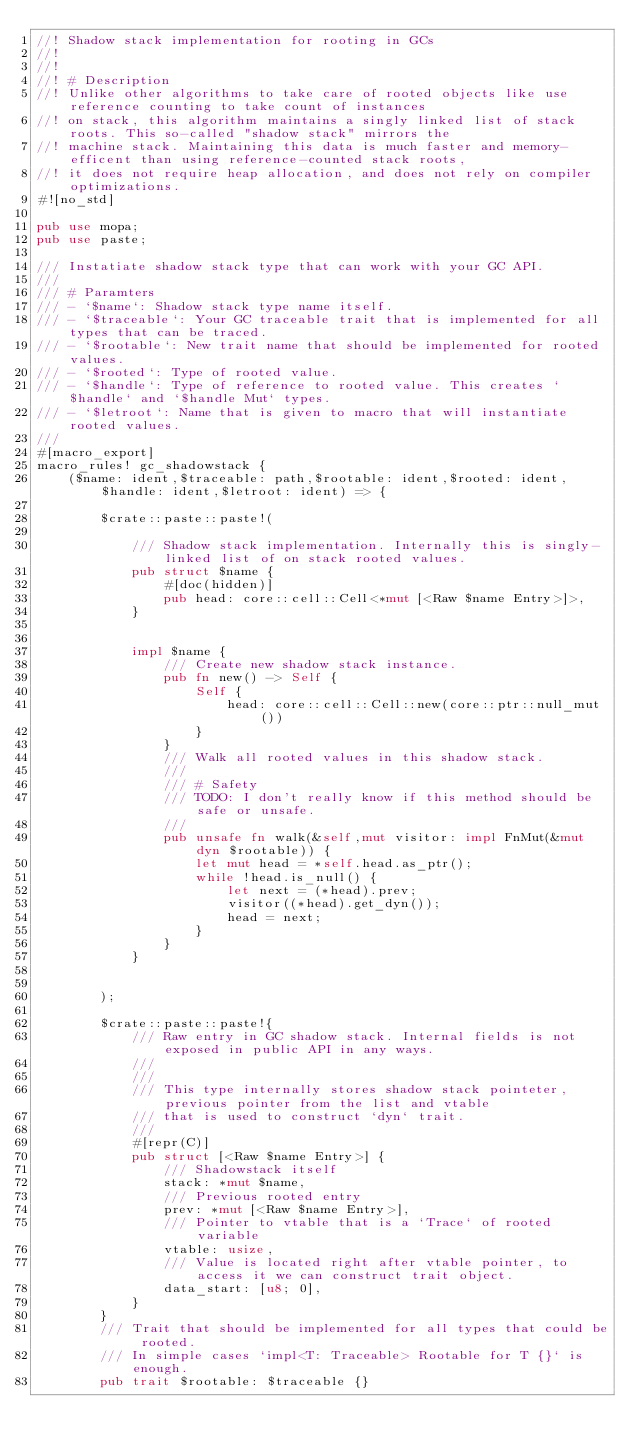Convert code to text. <code><loc_0><loc_0><loc_500><loc_500><_Rust_>//! Shadow stack implementation for rooting in GCs
//!
//!
//! # Description
//! Unlike other algorithms to take care of rooted objects like use reference counting to take count of instances
//! on stack, this algorithm maintains a singly linked list of stack roots. This so-called "shadow stack" mirrors the
//! machine stack. Maintaining this data is much faster and memory-efficent than using reference-counted stack roots,
//! it does not require heap allocation, and does not rely on compiler optimizations.
#![no_std]

pub use mopa;
pub use paste;

/// Instatiate shadow stack type that can work with your GC API.
///
/// # Paramters
/// - `$name`: Shadow stack type name itself.
/// - `$traceable`: Your GC traceable trait that is implemented for all types that can be traced.
/// - `$rootable`: New trait name that should be implemented for rooted values.
/// - `$rooted`: Type of rooted value.
/// - `$handle`: Type of reference to rooted value. This creates `$handle` and `$handle Mut` types.
/// - `$letroot`: Name that is given to macro that will instantiate rooted values.
///
#[macro_export]
macro_rules! gc_shadowstack {
    ($name: ident,$traceable: path,$rootable: ident,$rooted: ident,$handle: ident,$letroot: ident) => {

        $crate::paste::paste!(

            /// Shadow stack implementation. Internally this is singly-linked list of on stack rooted values.
            pub struct $name {
                #[doc(hidden)]
                pub head: core::cell::Cell<*mut [<Raw $name Entry>]>,
            }


            impl $name {
                /// Create new shadow stack instance.
                pub fn new() -> Self {
                    Self {
                        head: core::cell::Cell::new(core::ptr::null_mut())
                    }
                }
                /// Walk all rooted values in this shadow stack.
                ///
                /// # Safety
                /// TODO: I don't really know if this method should be safe or unsafe.
                ///
                pub unsafe fn walk(&self,mut visitor: impl FnMut(&mut dyn $rootable)) {
                    let mut head = *self.head.as_ptr();
                    while !head.is_null() {
                        let next = (*head).prev;
                        visitor((*head).get_dyn());
                        head = next;
                    }
                }
            }


        );

        $crate::paste::paste!{
            /// Raw entry in GC shadow stack. Internal fields is not exposed in public API in any ways.
            ///
            ///
            /// This type internally stores shadow stack pointeter,previous pointer from the list and vtable
            /// that is used to construct `dyn` trait.
            ///
            #[repr(C)]
            pub struct [<Raw $name Entry>] {
                /// Shadowstack itself
                stack: *mut $name,
                /// Previous rooted entry
                prev: *mut [<Raw $name Entry>],
                /// Pointer to vtable that is a `Trace` of rooted variable
                vtable: usize,
                /// Value is located right after vtable pointer, to access it we can construct trait object.
                data_start: [u8; 0],
            }
        }
        /// Trait that should be implemented for all types that could be rooted.
        /// In simple cases `impl<T: Traceable> Rootable for T {}` is enough.
        pub trait $rootable: $traceable {}</code> 